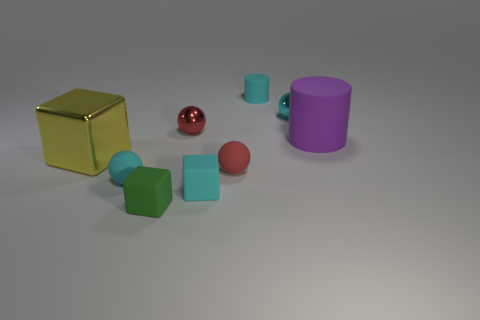What number of matte blocks are both behind the green object and left of the red metal sphere?
Your answer should be very brief. 0. Are there any spheres that have the same color as the tiny cylinder?
Your response must be concise. Yes. There is a green thing that is the same size as the cyan metallic ball; what shape is it?
Offer a very short reply. Cube. There is a big metallic block; are there any cyan metal objects behind it?
Your answer should be compact. Yes. Are the cube that is on the right side of the tiny red metallic object and the red sphere that is behind the big yellow metal object made of the same material?
Your answer should be compact. No. How many cyan rubber cylinders are the same size as the red metallic thing?
Provide a short and direct response. 1. What shape is the tiny metal object that is the same color as the tiny rubber cylinder?
Provide a succinct answer. Sphere. There is a tiny red sphere left of the tiny red matte thing; what is it made of?
Your answer should be very brief. Metal. What number of yellow objects have the same shape as the tiny red metal thing?
Your answer should be very brief. 0. There is a large purple thing that is the same material as the green thing; what shape is it?
Provide a succinct answer. Cylinder. 